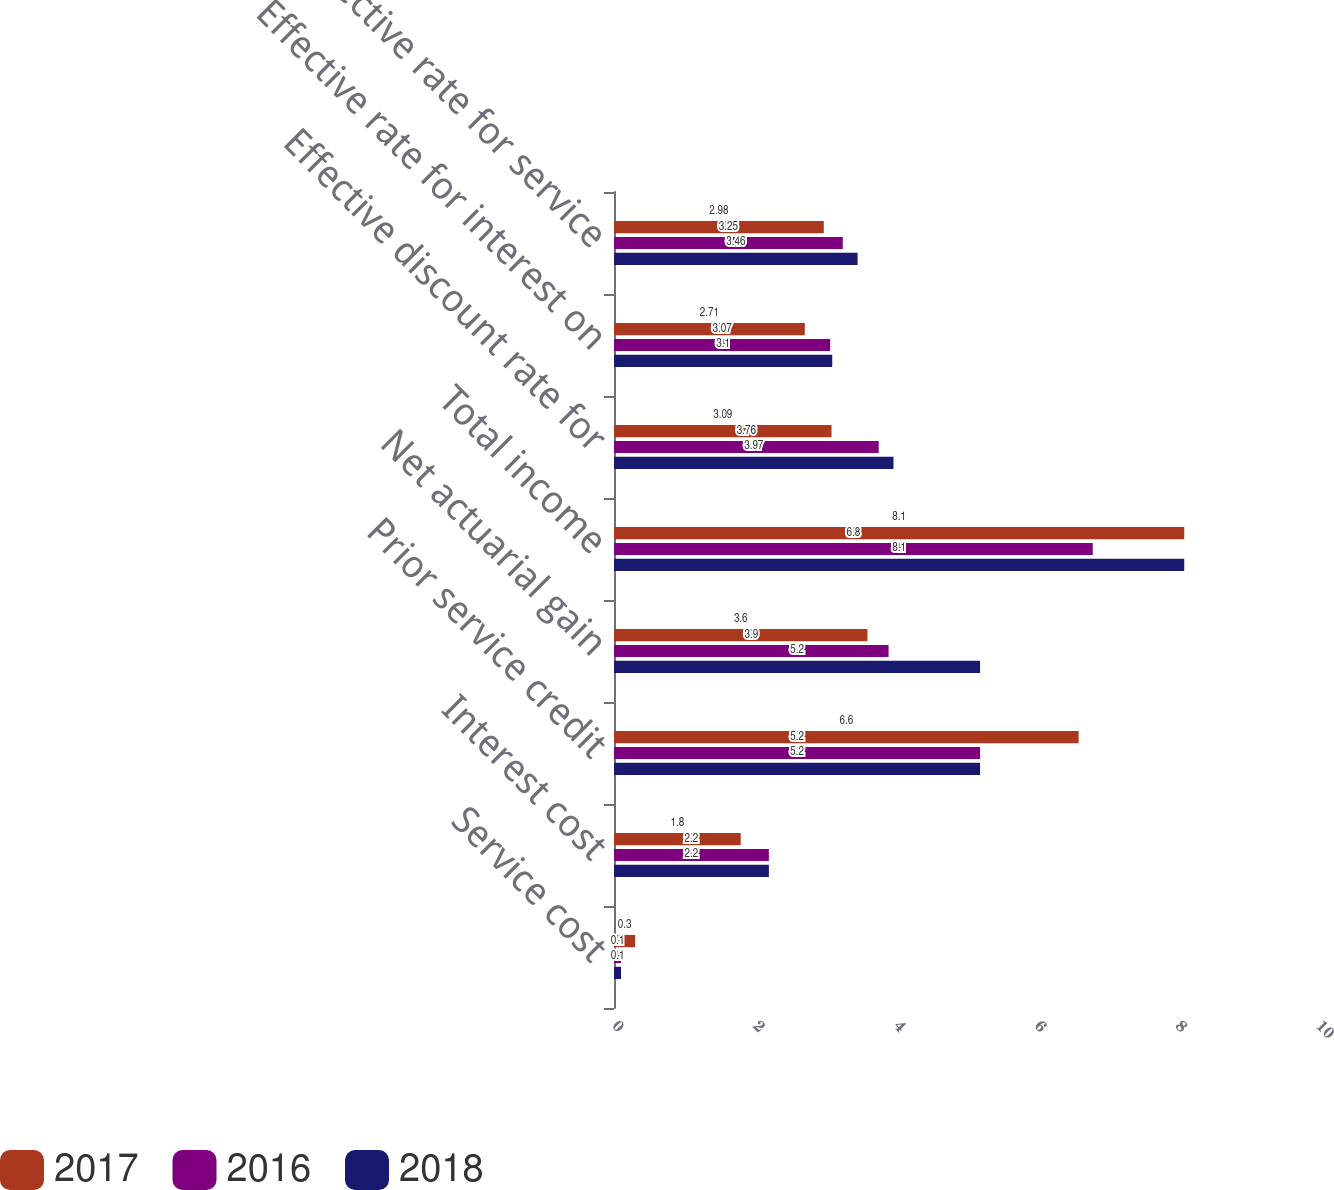Convert chart to OTSL. <chart><loc_0><loc_0><loc_500><loc_500><stacked_bar_chart><ecel><fcel>Service cost<fcel>Interest cost<fcel>Prior service credit<fcel>Net actuarial gain<fcel>Total income<fcel>Effective discount rate for<fcel>Effective rate for interest on<fcel>Effective rate for service<nl><fcel>2017<fcel>0.3<fcel>1.8<fcel>6.6<fcel>3.6<fcel>8.1<fcel>3.09<fcel>2.71<fcel>2.98<nl><fcel>2016<fcel>0.1<fcel>2.2<fcel>5.2<fcel>3.9<fcel>6.8<fcel>3.76<fcel>3.07<fcel>3.25<nl><fcel>2018<fcel>0.1<fcel>2.2<fcel>5.2<fcel>5.2<fcel>8.1<fcel>3.97<fcel>3.1<fcel>3.46<nl></chart> 